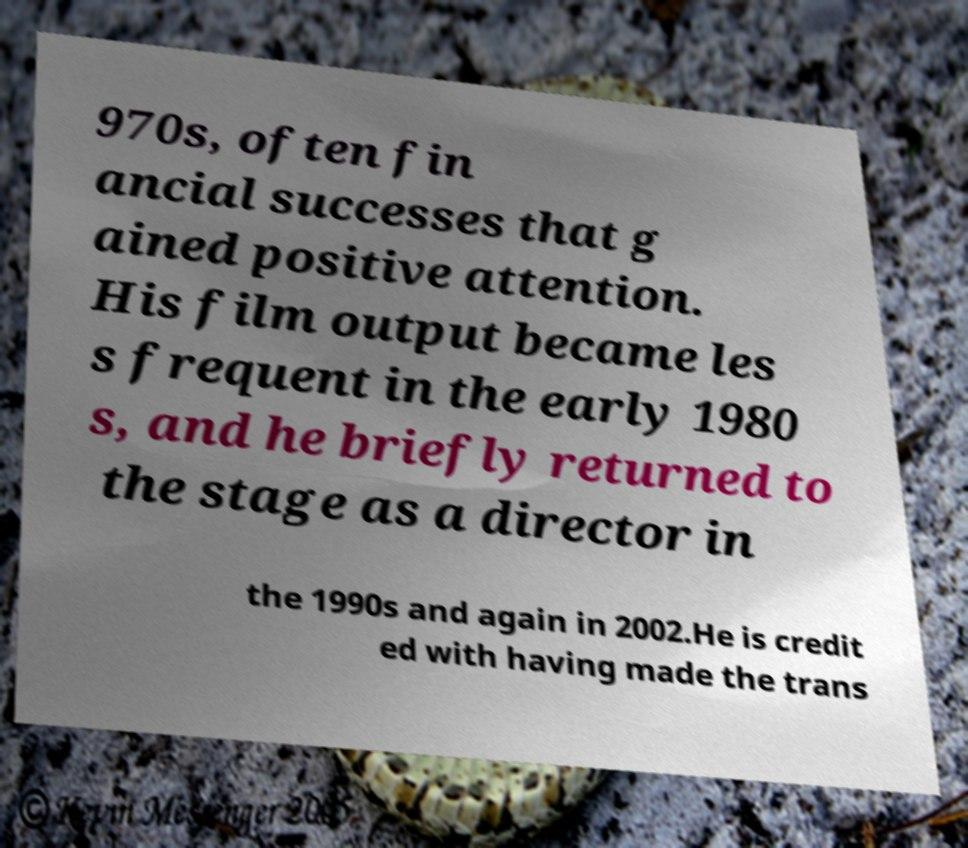What messages or text are displayed in this image? I need them in a readable, typed format. 970s, often fin ancial successes that g ained positive attention. His film output became les s frequent in the early 1980 s, and he briefly returned to the stage as a director in the 1990s and again in 2002.He is credit ed with having made the trans 